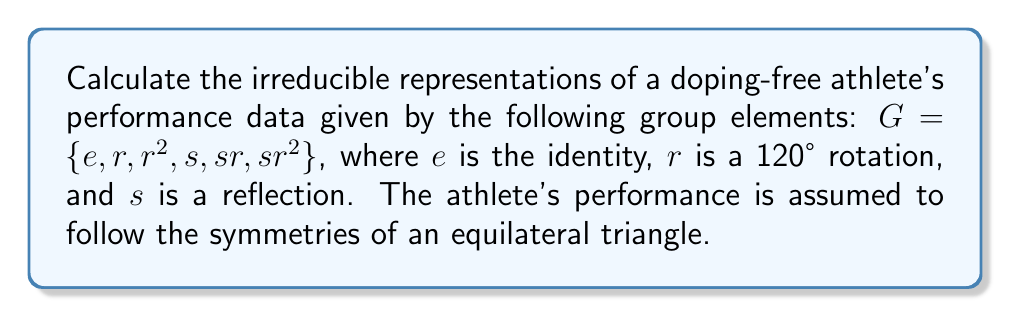Help me with this question. 1) First, we identify the group as $D_3$, the dihedral group of order 6.

2) To find the irreducible representations, we need to determine the conjugacy classes:
   - $\{e\}$
   - $\{r, r^2\}$
   - $\{s, sr, sr^2\}$

3) The number of irreducible representations equals the number of conjugacy classes, which is 3.

4) We know that $\sum_{i} (d_i)^2 = |G| = 6$, where $d_i$ are the dimensions of the irreducible representations.

5) Given that one irreducible representation is always the trivial representation of dimension 1, and another must be 2-dimensional (as 6 = 1^2 + 1^2 + 2^2), we can deduce that the irreducible representations are of dimensions 1, 1, and 2.

6) The character table for $D_3$ is:

   $$\begin{array}{c|ccc}
      & \{e\} & \{r,r^2\} & \{s,sr,sr^2\} \\
   \hline
   \chi_1 & 1 & 1 & 1 \\
   \chi_2 & 1 & 1 & -1 \\
   \chi_3 & 2 & -1 & 0
   \end{array}$$

7) The irreducible representations are:
   - $\rho_1$: The trivial representation (all elements map to 1)
   - $\rho_2$: The sign representation (rotations to 1, reflections to -1)
   - $\rho_3$: The 2-dimensional representation, given by:
     $$\rho_3(e) = \begin{pmatrix} 1 & 0 \\ 0 & 1 \end{pmatrix}$$
     $$\rho_3(r) = \begin{pmatrix} -\frac{1}{2} & -\frac{\sqrt{3}}{2} \\ \frac{\sqrt{3}}{2} & -\frac{1}{2} \end{pmatrix}$$
     $$\rho_3(s) = \begin{pmatrix} 1 & 0 \\ 0 & -1 \end{pmatrix}$$
Answer: $\rho_1(1), \rho_2(\pm1), \rho_3(2\times2)$ 